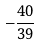Convert formula to latex. <formula><loc_0><loc_0><loc_500><loc_500>- { \frac { 4 0 } { 3 9 } }</formula> 